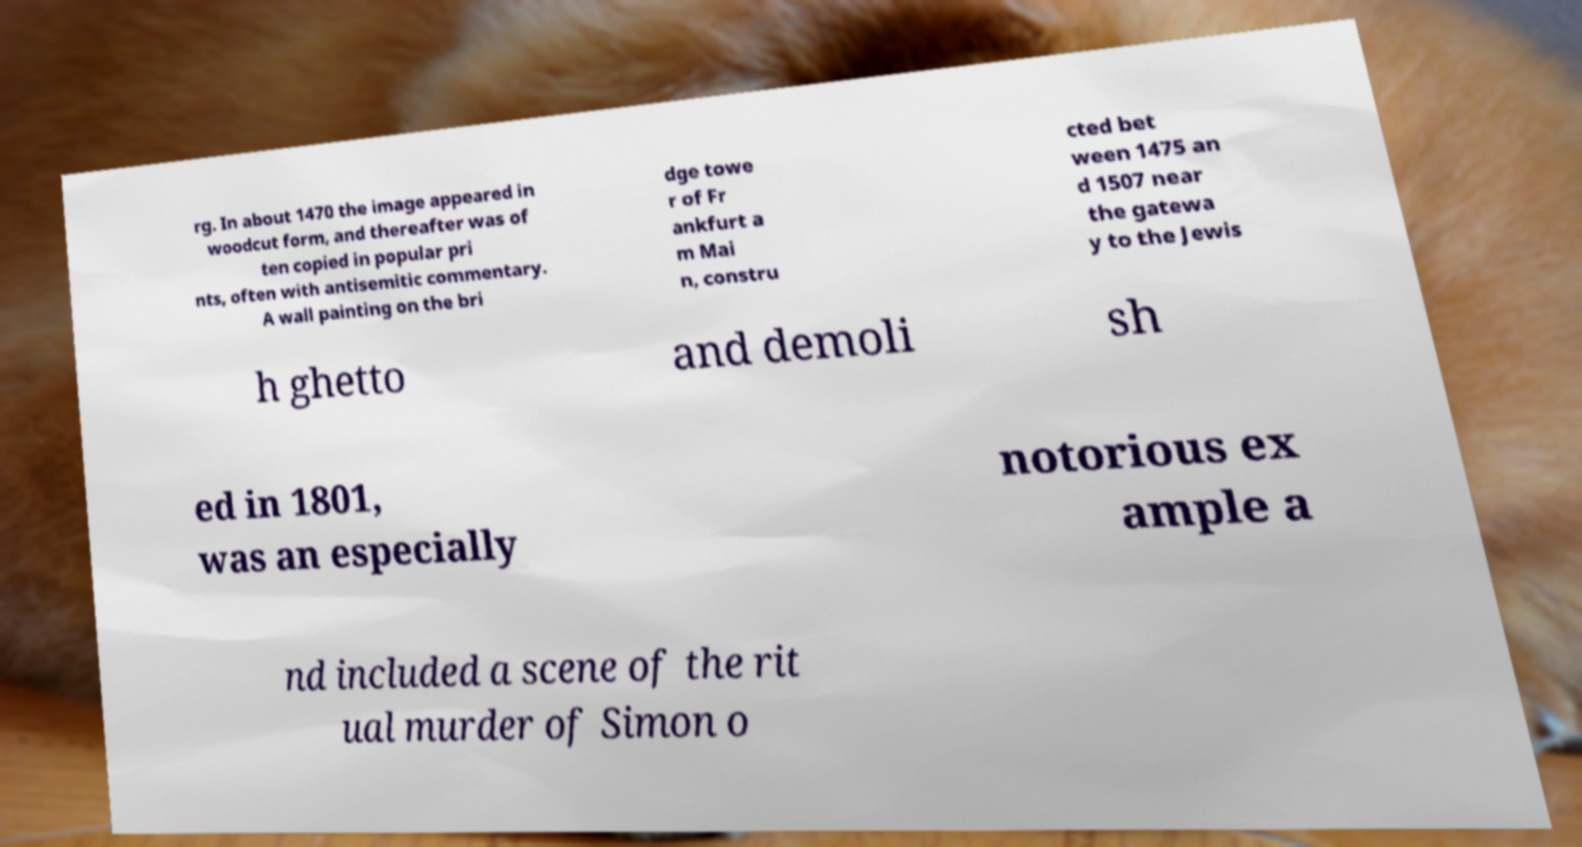Please identify and transcribe the text found in this image. rg. In about 1470 the image appeared in woodcut form, and thereafter was of ten copied in popular pri nts, often with antisemitic commentary. A wall painting on the bri dge towe r of Fr ankfurt a m Mai n, constru cted bet ween 1475 an d 1507 near the gatewa y to the Jewis h ghetto and demoli sh ed in 1801, was an especially notorious ex ample a nd included a scene of the rit ual murder of Simon o 